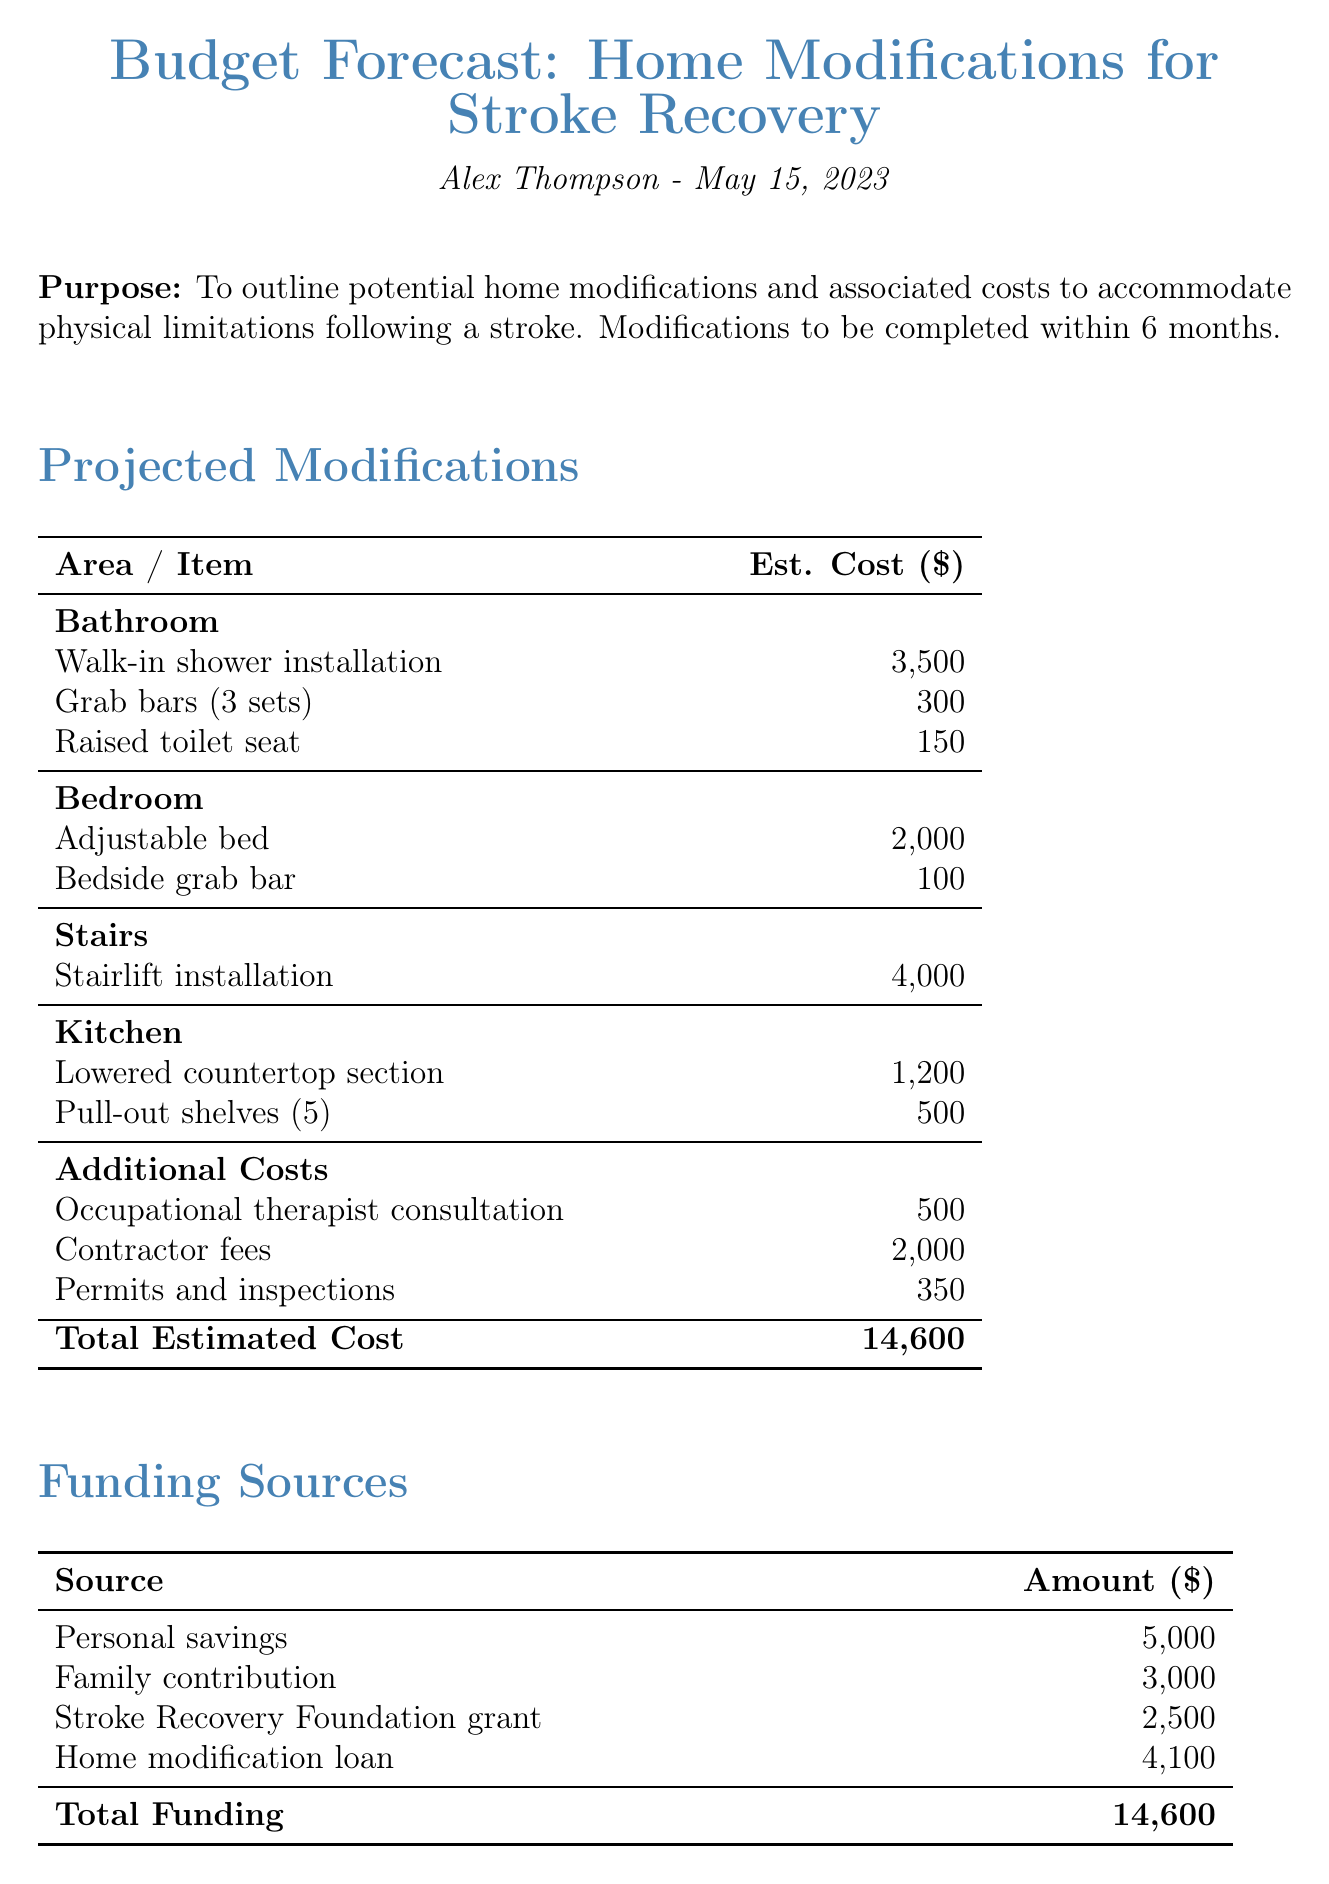What is the title of the document? The title is mentioned at the beginning of the document under the header section.
Answer: Budget Forecast: Home Modifications for Stroke Recovery Who is the client? The client's name is specified in the document's header.
Answer: Alex Thompson What is the estimated cost for a walk-in shower installation? The estimated cost for the walk-in shower installation is found in the projected modifications section.
Answer: 3500 How much is allocated for contractor fees? The amount for contractor fees is listed under additional costs in the document.
Answer: 2000 What is the total estimated cost for the modifications? The total estimated cost is found at the bottom of the projected modifications section.
Answer: 14600 What is the total funding amount? The total funding amount can be found in the funding sources section of the document.
Answer: 14600 Which funding source contributes 2500? The specific funding source that provides 2500 is mentioned in the funding sources section.
Answer: Stroke Recovery Foundation grant What are the next steps mentioned in the conclusion? The next steps are outlined at the end of the conclusion section.
Answer: Consult with healthcare providers and contractors to finalize modification plans and begin implementation What is the timeframe for modifications to be completed? The timeframe is provided in the introduction of the document.
Answer: 6 months 